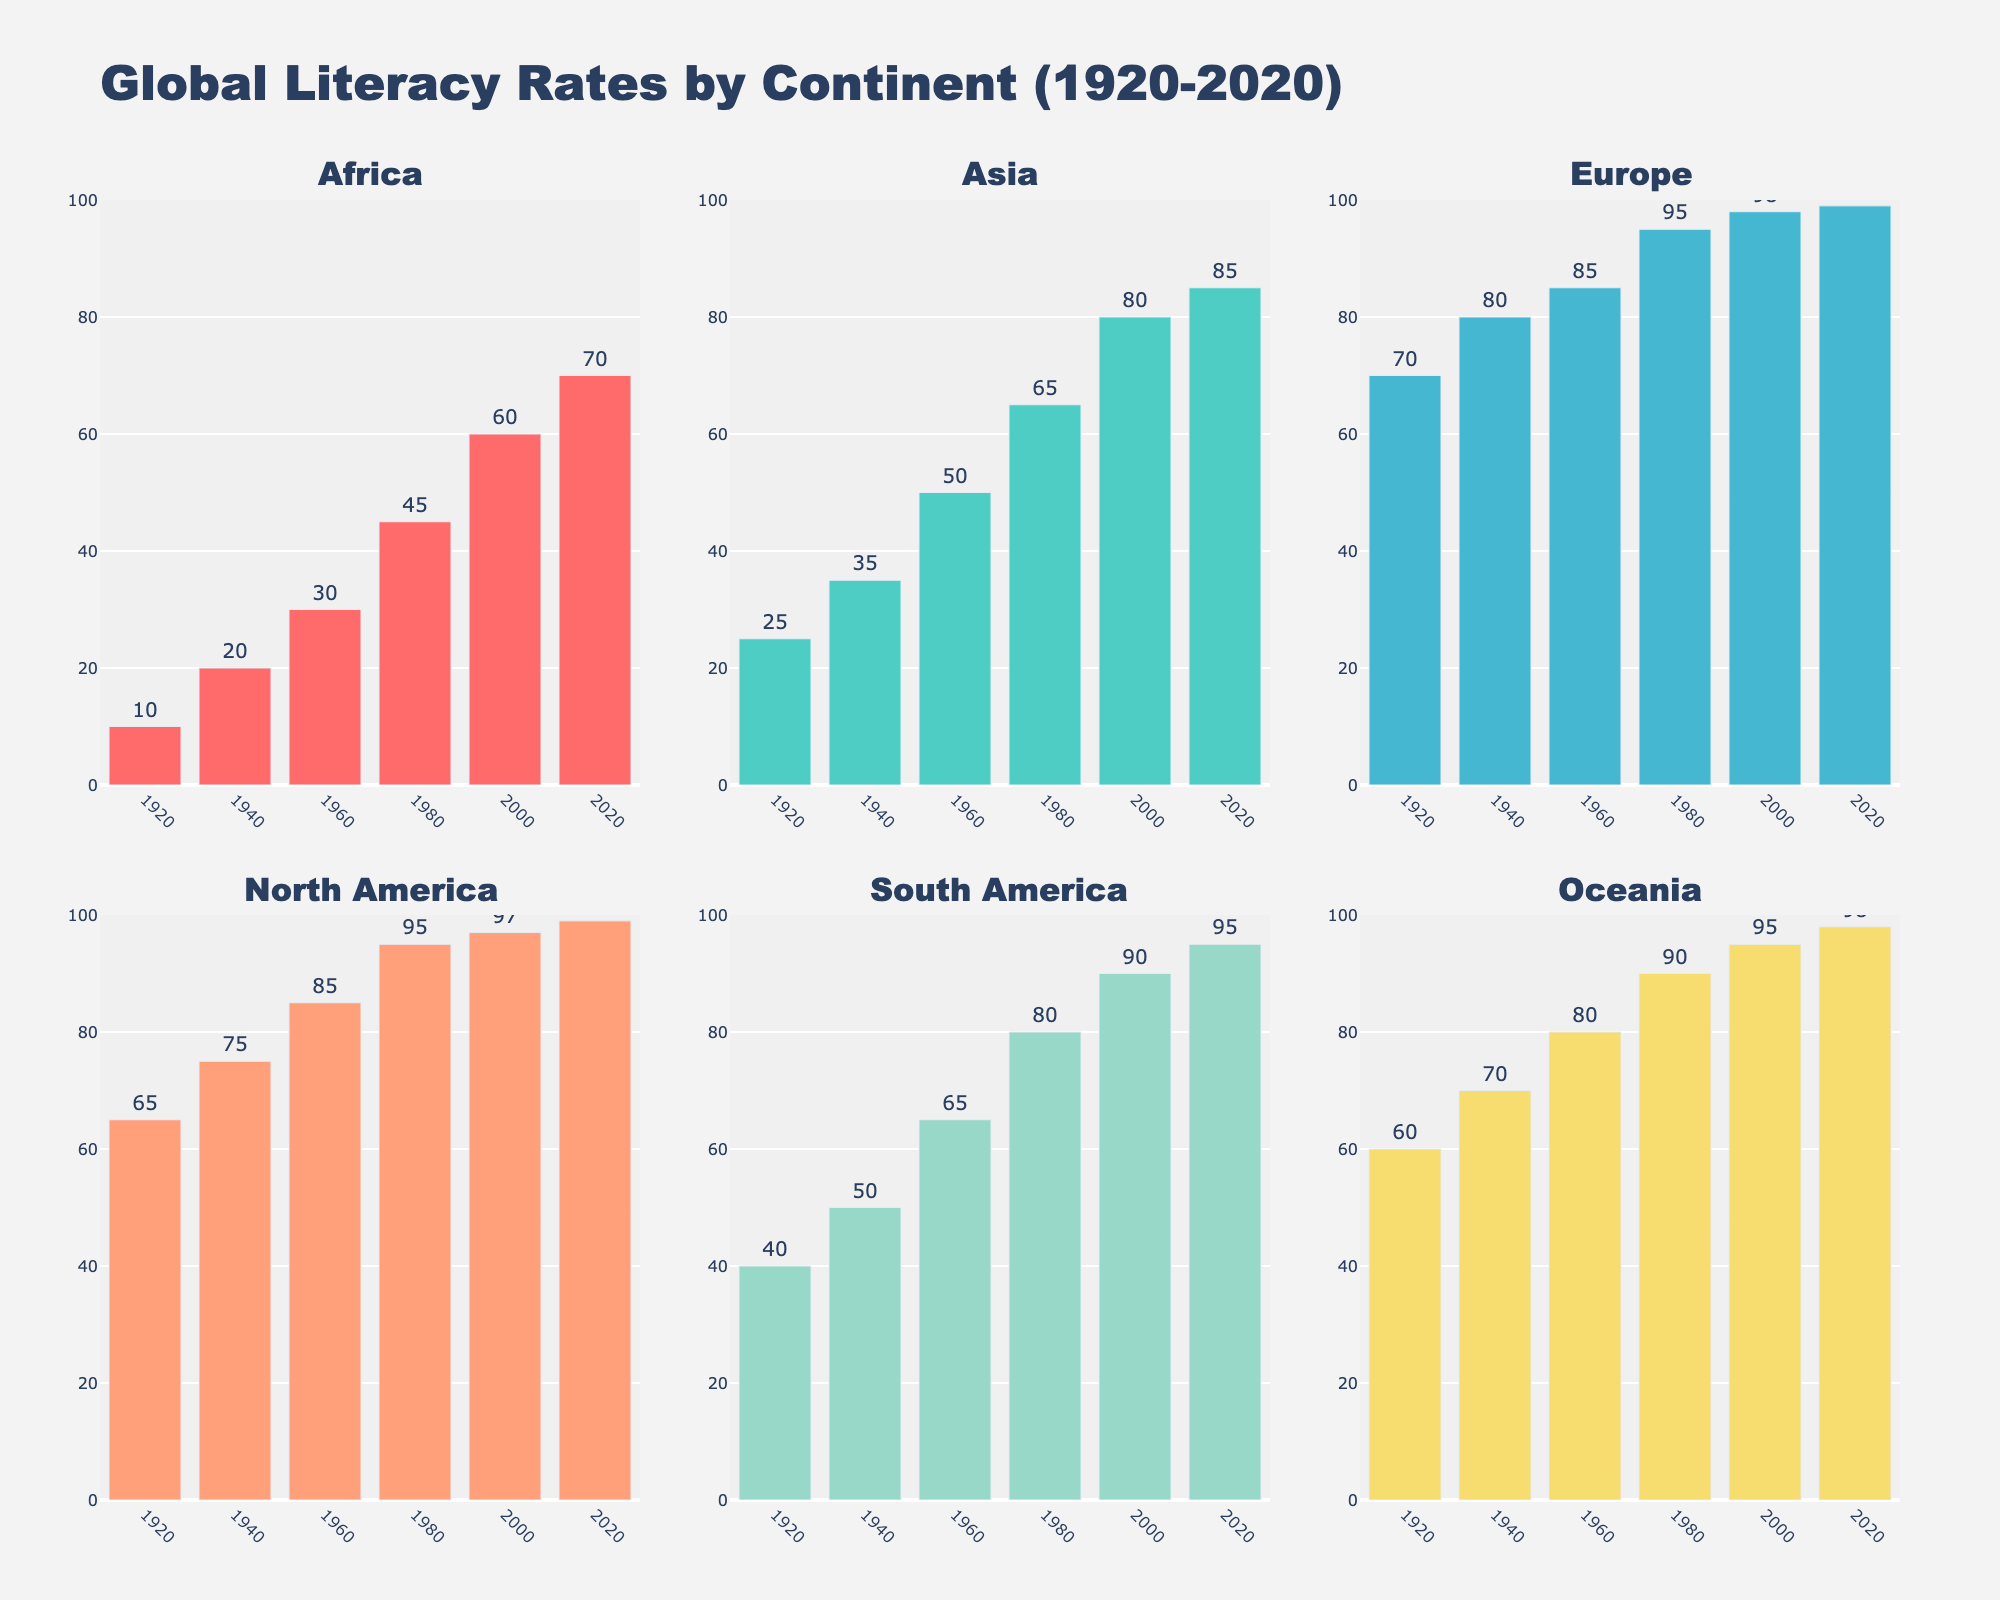What continent had the highest literacy rate in 1920? The figure shows that Europe had the highest literacy rate in 1920, reaching up to 70%.
Answer: Europe Which continents had similar literacy rates in 2020, and how do they compare? In 2020, both Europe and North America had literacy rates of 99%, indicating similar levels.
Answer: Europe and North America Which continent saw the biggest increase in literacy rate from 1920 to 2020? To find the largest increase, subtract the 1920 rate from the 2020 rate for each continent. Africa saw an increase from 10% to 70%, which is a 60% increase, the largest among all.
Answer: Africa How does the literacy rate of Asia in 1960 compare to that of South America in 1980? The bar for Asia in 1960 shows a literacy rate of 50%, while South America in 1980 is 80%. Comparing these rates, South America's rate in 1980 is higher.
Answer: South America By how many percentage points did the literacy rate in Oceania increase from 1960 to 2020? Subtract the literacy rate of Oceania in 1960 (80%) from its rate in 2020 (98%). The increase is 98% - 80% = 18 percentage points.
Answer: 18 What is the average literacy rate for Africa across all years presented? Add the literacy rates for Africa across all years (10 + 20 + 30 + 45 + 60 + 70) and then divide by the number of years (6). The average is (10 + 20 + 30 + 45 + 60 + 70)/6 = 235/6 ≈ 39.17.
Answer: 39.17 Which two continents had nearly identical literacy rates in 2000 and how close were they? Comparing the figures, Europe had a literacy rate of 98% in 2000 and North America had a literacy rate of 97%. These rates are nearly identical, with only a 1% difference.
Answer: Europe and North America, 1% What trend can you observe in the literacy rates of South America from 1920 to 2020? The trend in the figure shows a consistent and significant increase in literacy rates for South America from 40% in 1920 to 95% in 2020.
Answer: Consistent increase In which decades did Africa experience the most significant increase in literacy rate, according to the chart? Africa's literacy rate increased the most from 1960 to 1980, going from 30% to 45%, a 15% increase.
Answer: 1960 to 1980 What year did Asia surpass a literacy rate of 50%, and which continent reached this milestone earlier? The figure indicates that Asia surpassed a 50% literacy rate in 1960. Europe had already surpassed this milestone by 1920.
Answer: 1960, Europe 